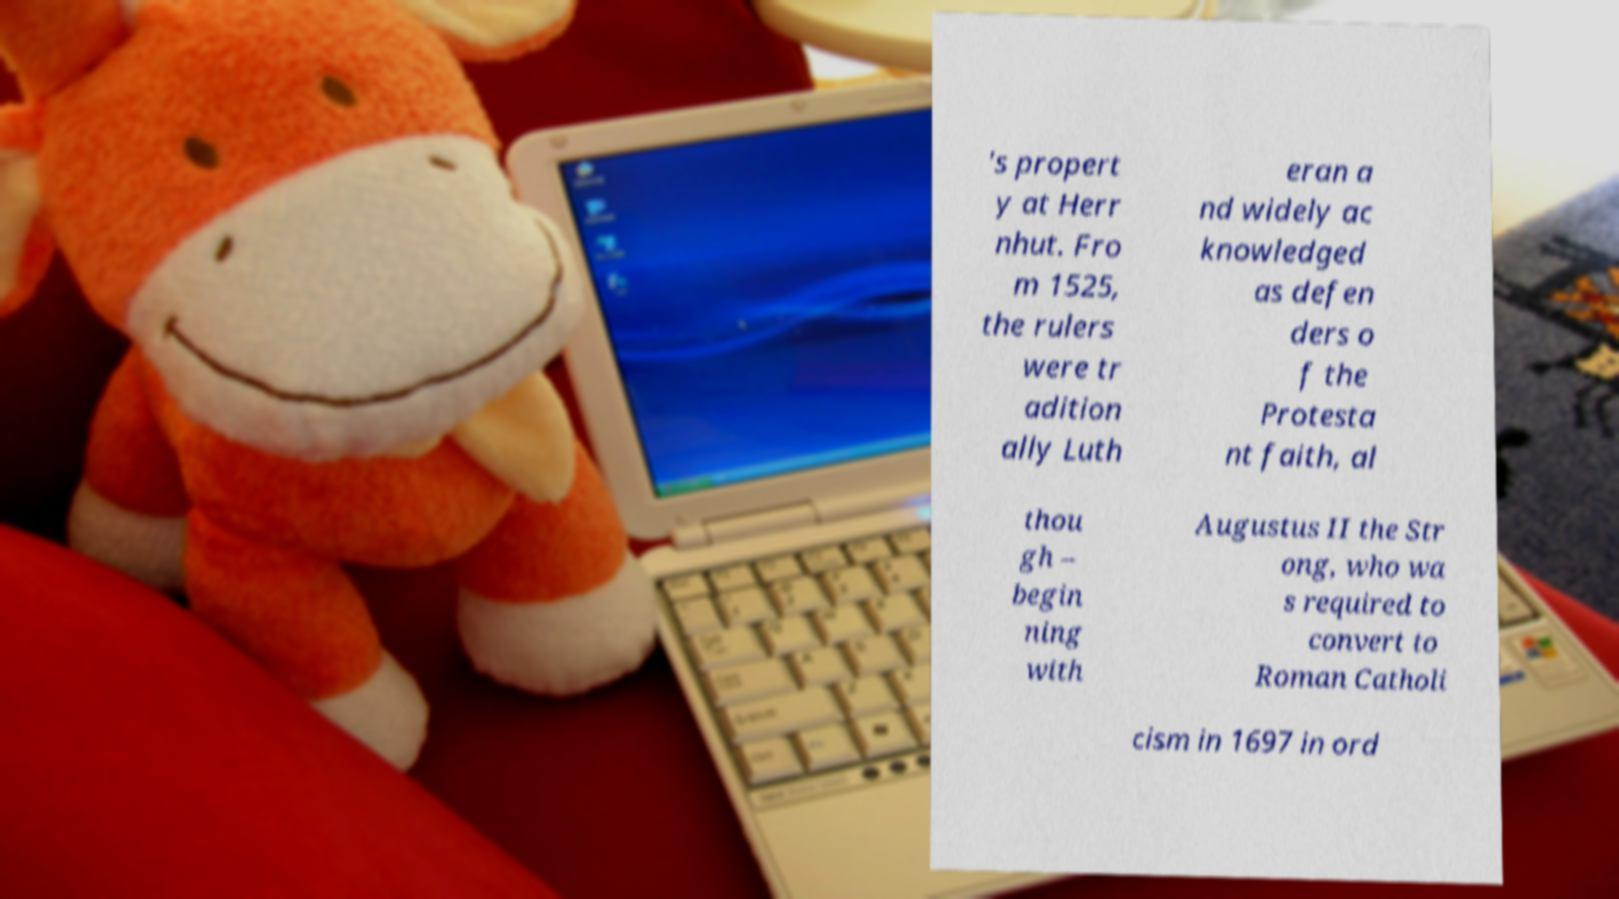Could you extract and type out the text from this image? 's propert y at Herr nhut. Fro m 1525, the rulers were tr adition ally Luth eran a nd widely ac knowledged as defen ders o f the Protesta nt faith, al thou gh – begin ning with Augustus II the Str ong, who wa s required to convert to Roman Catholi cism in 1697 in ord 